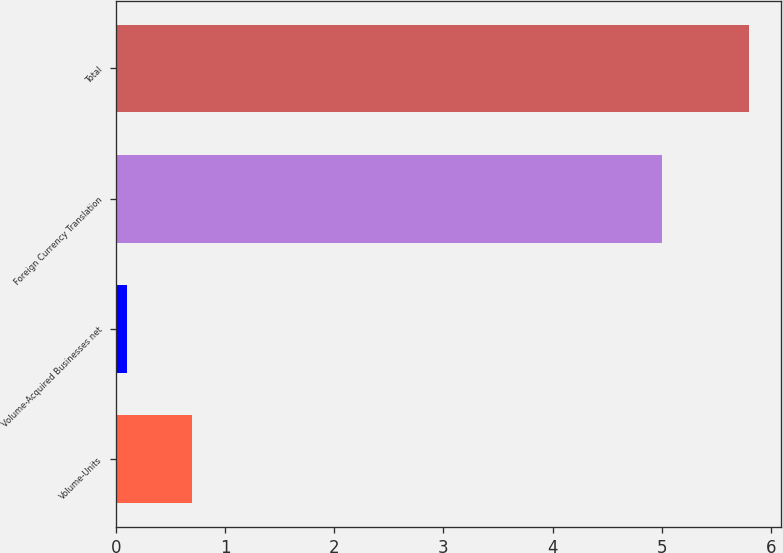Convert chart. <chart><loc_0><loc_0><loc_500><loc_500><bar_chart><fcel>Volume-Units<fcel>Volume-Acquired Businesses net<fcel>Foreign Currency Translation<fcel>Total<nl><fcel>0.7<fcel>0.1<fcel>5<fcel>5.8<nl></chart> 